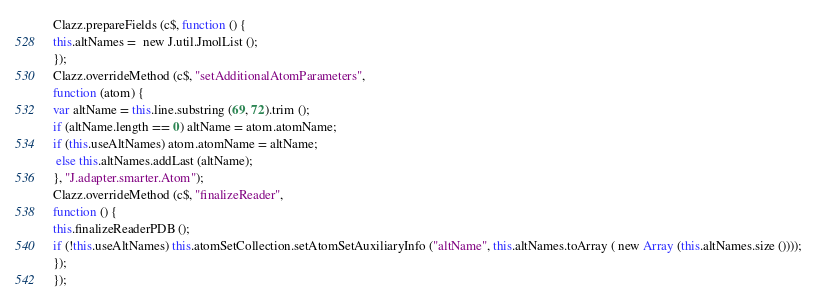Convert code to text. <code><loc_0><loc_0><loc_500><loc_500><_JavaScript_>Clazz.prepareFields (c$, function () {
this.altNames =  new J.util.JmolList ();
});
Clazz.overrideMethod (c$, "setAdditionalAtomParameters", 
function (atom) {
var altName = this.line.substring (69, 72).trim ();
if (altName.length == 0) altName = atom.atomName;
if (this.useAltNames) atom.atomName = altName;
 else this.altNames.addLast (altName);
}, "J.adapter.smarter.Atom");
Clazz.overrideMethod (c$, "finalizeReader", 
function () {
this.finalizeReaderPDB ();
if (!this.useAltNames) this.atomSetCollection.setAtomSetAuxiliaryInfo ("altName", this.altNames.toArray ( new Array (this.altNames.size ())));
});
});
</code> 